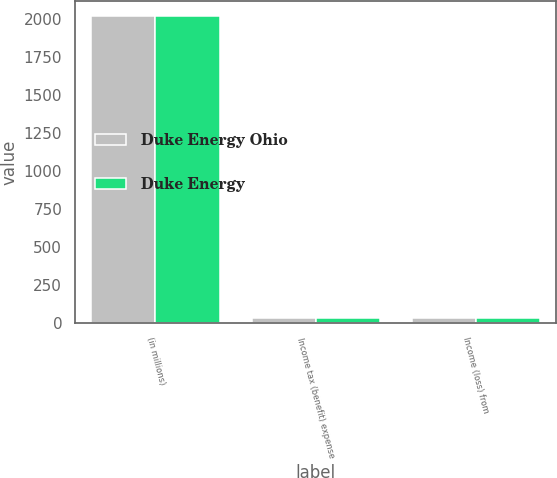<chart> <loc_0><loc_0><loc_500><loc_500><stacked_bar_chart><ecel><fcel>(in millions)<fcel>Income tax (benefit) expense<fcel>Income (loss) from<nl><fcel>Duke Energy Ohio<fcel>2016<fcel>36<fcel>36<nl><fcel>Duke Energy<fcel>2016<fcel>36<fcel>36<nl></chart> 